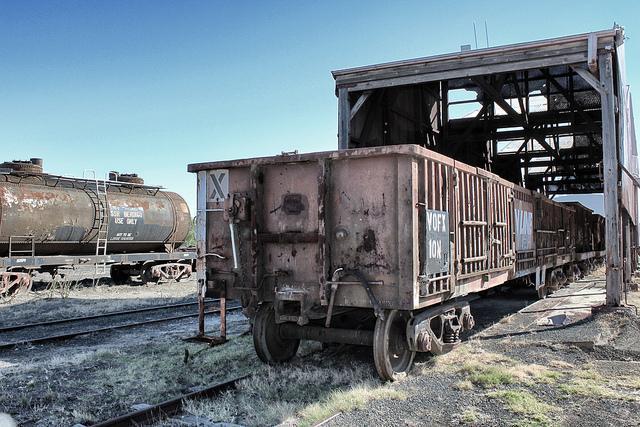How many trains are in the photo?
Give a very brief answer. 2. 